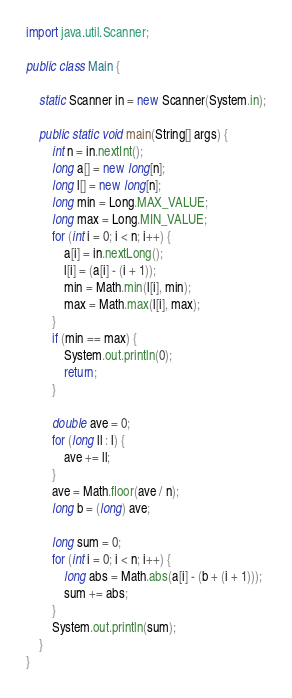<code> <loc_0><loc_0><loc_500><loc_500><_Java_>
import java.util.Scanner;

public class Main {

	static Scanner in = new Scanner(System.in);

	public static void main(String[] args) {
		int n = in.nextInt();
		long a[] = new long[n];
		long l[] = new long[n];
		long min = Long.MAX_VALUE;
		long max = Long.MIN_VALUE;
		for (int i = 0; i < n; i++) {
			a[i] = in.nextLong();
			l[i] = (a[i] - (i + 1));
			min = Math.min(l[i], min);
			max = Math.max(l[i], max);
		}
		if (min == max) {
			System.out.println(0);
			return;
		}

		double ave = 0;
		for (long ll : l) {
			ave += ll;
		}
		ave = Math.floor(ave / n);
		long b = (long) ave;

		long sum = 0;
		for (int i = 0; i < n; i++) {
			long abs = Math.abs(a[i] - (b + (i + 1)));
			sum += abs;
		}
		System.out.println(sum);
	}
}
</code> 